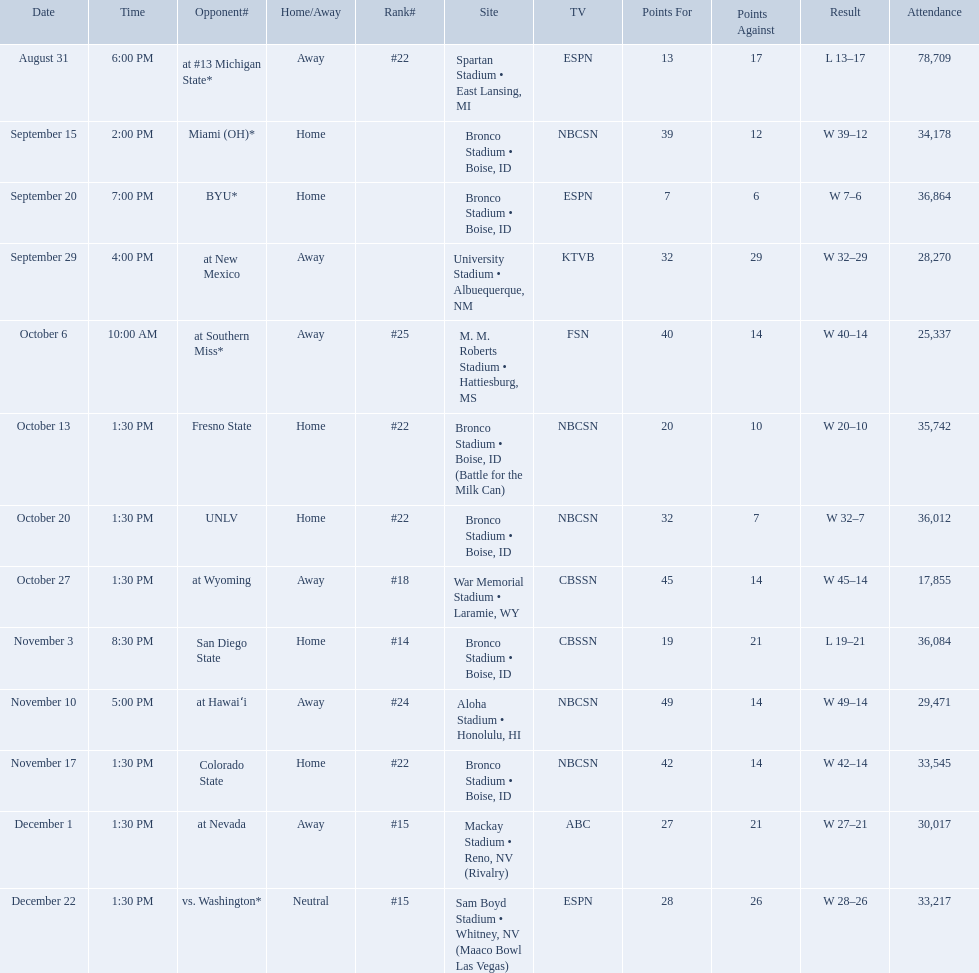What was the team's listed rankings for the season? #22, , , , #25, #22, #22, #18, #14, #24, #22, #15, #15. Which of these ranks is the best? #14. Who were all of the opponents? At #13 michigan state*, miami (oh)*, byu*, at new mexico, at southern miss*, fresno state, unlv, at wyoming, san diego state, at hawaiʻi, colorado state, at nevada, vs. washington*. Who did they face on november 3rd? San Diego State. What rank were they on november 3rd? #14. Who were all the opponents for boise state? At #13 michigan state*, miami (oh)*, byu*, at new mexico, at southern miss*, fresno state, unlv, at wyoming, san diego state, at hawaiʻi, colorado state, at nevada, vs. washington*. Which opponents were ranked? At #13 michigan state*, #22, at southern miss*, #25, fresno state, #22, unlv, #22, at wyoming, #18, san diego state, #14. Which opponent had the highest rank? San Diego State. 